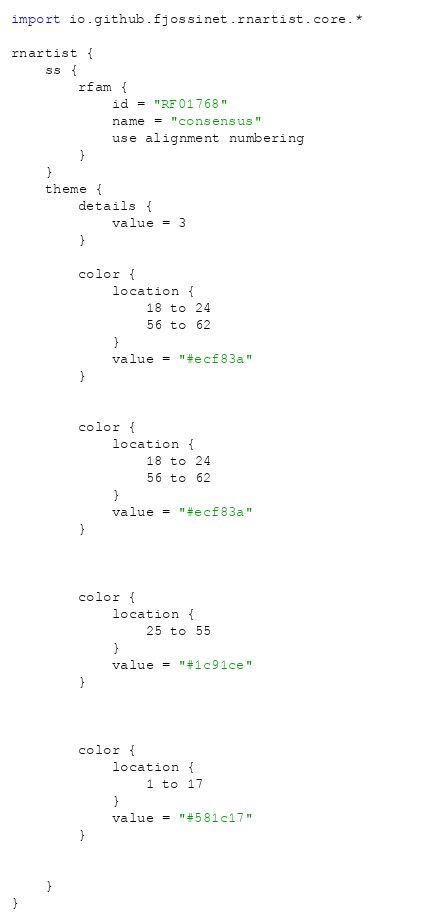<code> <loc_0><loc_0><loc_500><loc_500><_Kotlin_>import io.github.fjossinet.rnartist.core.*      

rnartist {
    ss {
        rfam {
            id = "RF01768"
            name = "consensus"
            use alignment numbering
        }
    }
    theme {
        details { 
            value = 3
        }

        color {
            location {
                18 to 24
                56 to 62
            }
            value = "#ecf83a"
        }


        color {
            location {
                18 to 24
                56 to 62
            }
            value = "#ecf83a"
        }



        color {
            location {
                25 to 55
            }
            value = "#1c91ce"
        }



        color {
            location {
                1 to 17
            }
            value = "#581c17"
        }


    }
}           </code> 